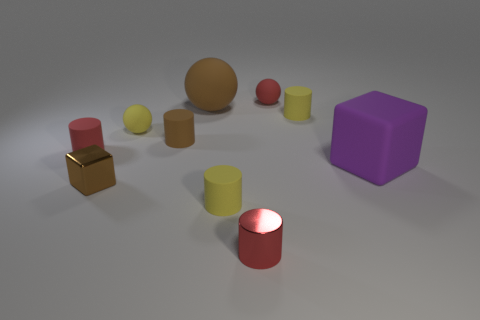Is there any other thing that is made of the same material as the small yellow sphere?
Offer a very short reply. Yes. How many objects are small cylinders that are right of the big brown ball or large gray spheres?
Provide a short and direct response. 3. There is a tiny yellow rubber object right of the small red metallic cylinder that is right of the brown block; are there any large purple cubes behind it?
Ensure brevity in your answer.  No. Are there an equal number of large gray matte cylinders and small yellow cylinders?
Your answer should be very brief. No. What number of purple rubber cubes are there?
Your answer should be very brief. 1. What number of things are either cylinders that are on the right side of the small metal cylinder or red cylinders to the right of the tiny brown metal block?
Your answer should be very brief. 2. There is a metallic object on the right side of the brown cube; is its size the same as the small brown metal block?
Offer a very short reply. Yes. There is another thing that is the same shape as the large purple rubber object; what size is it?
Provide a short and direct response. Small. What is the material of the red cylinder that is the same size as the red metallic thing?
Make the answer very short. Rubber. There is another red thing that is the same shape as the red metal thing; what is its material?
Ensure brevity in your answer.  Rubber. 